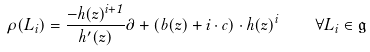Convert formula to latex. <formula><loc_0><loc_0><loc_500><loc_500>\rho ( L _ { i } ) = \frac { - h ( z ) ^ { i + 1 } } { h ^ { \prime } ( z ) } \partial + ( b ( z ) + i \cdot c ) \cdot h ( z ) ^ { i } \quad \forall L _ { i } \in { \mathfrak { g } }</formula> 